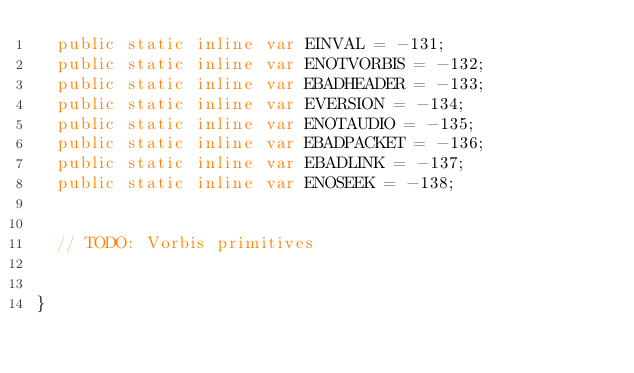<code> <loc_0><loc_0><loc_500><loc_500><_Haxe_>	public static inline var EINVAL = -131;
	public static inline var ENOTVORBIS = -132;
	public static inline var EBADHEADER = -133;
	public static inline var EVERSION = -134;
	public static inline var ENOTAUDIO = -135;
	public static inline var EBADPACKET = -136;
	public static inline var EBADLINK = -137;
	public static inline var ENOSEEK = -138;
	
	
	// TODO: Vorbis primitives
	
	
}</code> 